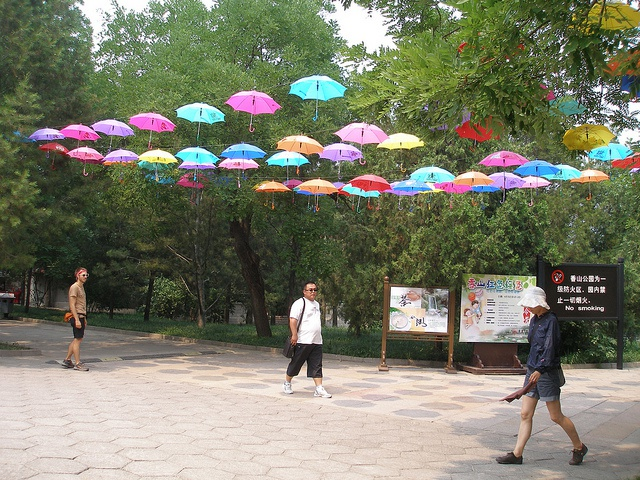Describe the objects in this image and their specific colors. I can see umbrella in darkgreen, lavender, violet, and lightblue tones, people in darkgreen, black, gray, and darkgray tones, people in darkgreen, white, black, tan, and brown tones, people in darkgreen, gray, black, and tan tones, and umbrella in darkgreen, cyan, white, and teal tones in this image. 